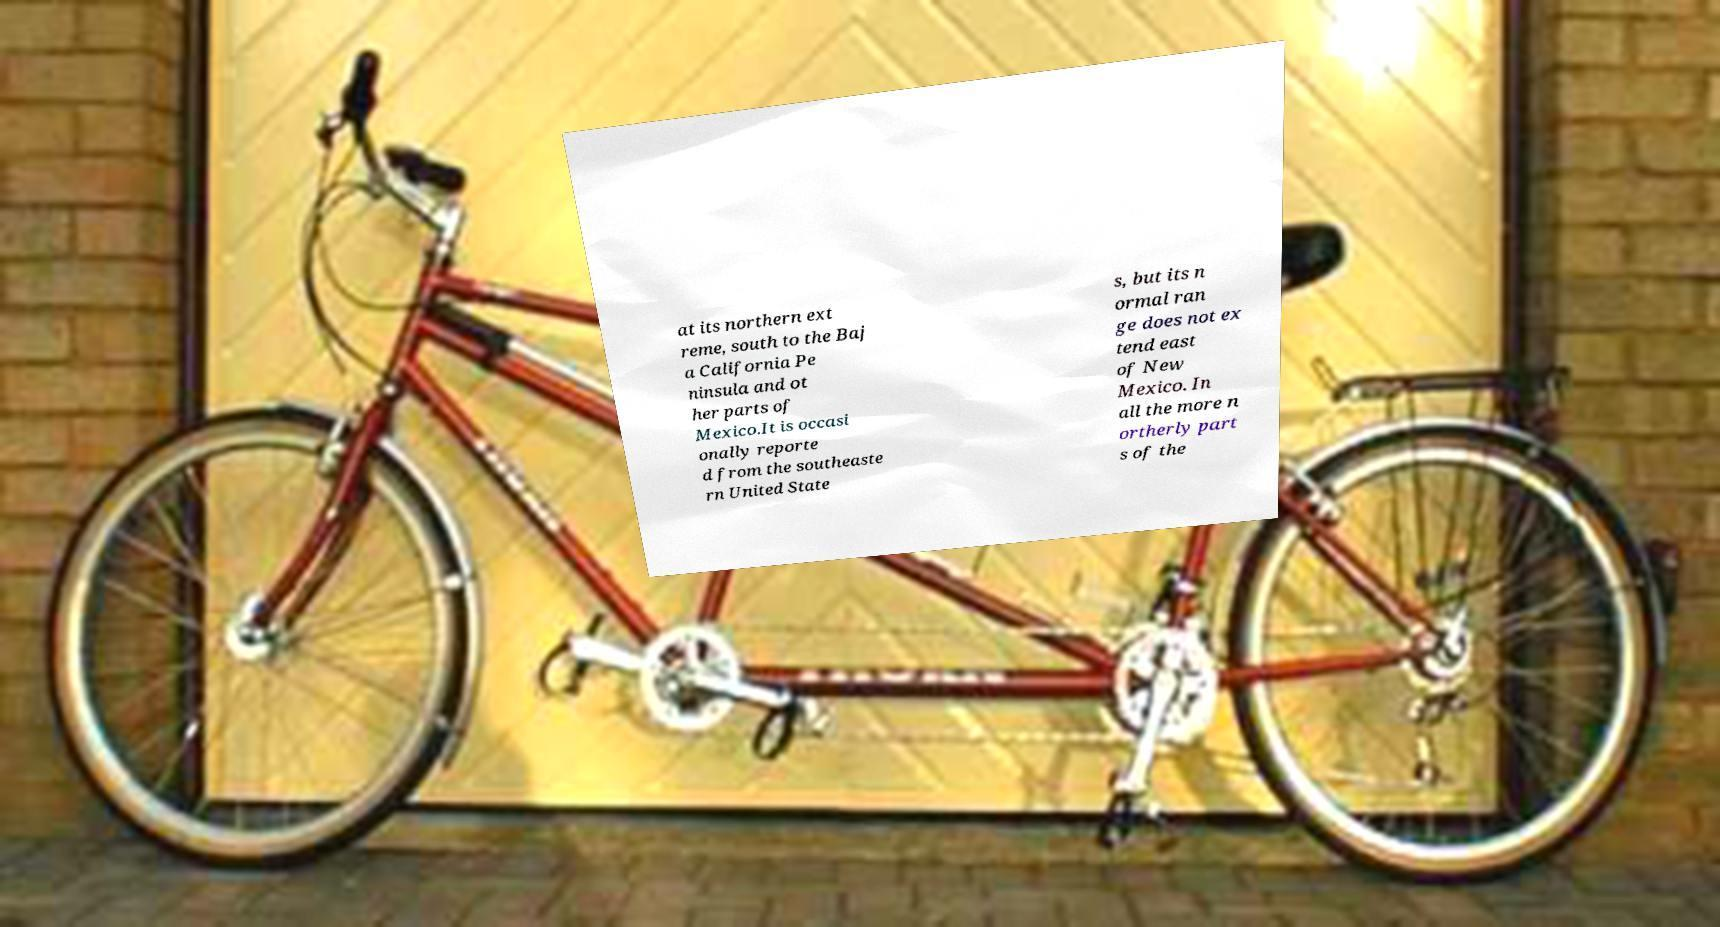I need the written content from this picture converted into text. Can you do that? at its northern ext reme, south to the Baj a California Pe ninsula and ot her parts of Mexico.It is occasi onally reporte d from the southeaste rn United State s, but its n ormal ran ge does not ex tend east of New Mexico. In all the more n ortherly part s of the 